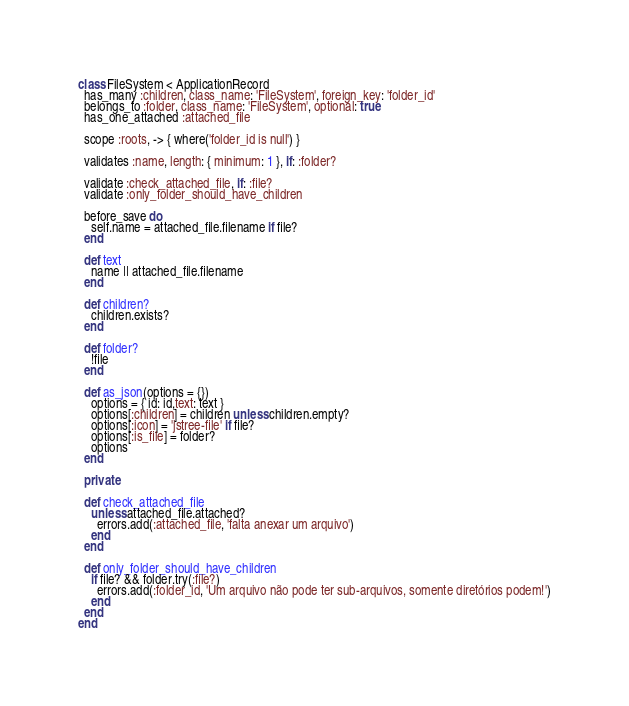Convert code to text. <code><loc_0><loc_0><loc_500><loc_500><_Ruby_>class FileSystem < ApplicationRecord
  has_many :children, class_name: 'FileSystem', foreign_key: 'folder_id'
  belongs_to :folder, class_name: 'FileSystem', optional: true
  has_one_attached :attached_file

  scope :roots, -> { where('folder_id is null') }

  validates :name, length: { minimum: 1 }, if: :folder?

  validate :check_attached_file, if: :file?
  validate :only_folder_should_have_children

  before_save do
    self.name = attached_file.filename if file?
  end

  def text
    name || attached_file.filename
  end

  def children?
    children.exists?
  end

  def folder?
    !file
  end

  def as_json(options = {})
    options = { id: id,text: text }
    options[:children] = children unless children.empty?
    options[:icon] = 'jstree-file' if file?
    options[:is_file] = folder?
    options
  end

  private

  def check_attached_file
    unless attached_file.attached?
      errors.add(:attached_file, 'falta anexar um arquivo')
    end
  end

  def only_folder_should_have_children
    if file? && folder.try(:file?)
      errors.add(:folder_id, 'Um arquivo não pode ter sub-arquivos, somente diretórios podem!')
    end
  end
end
</code> 